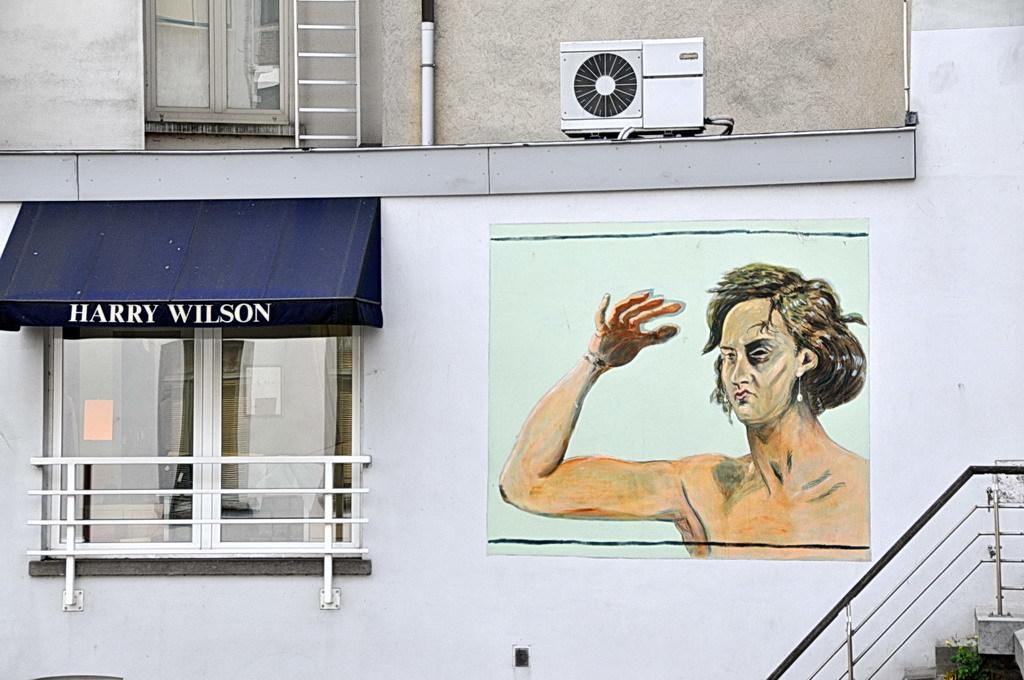Provide a one-sentence caption for the provided image. A shopfront labeled "Harry Wilson" sits next to a nicely done mural. 